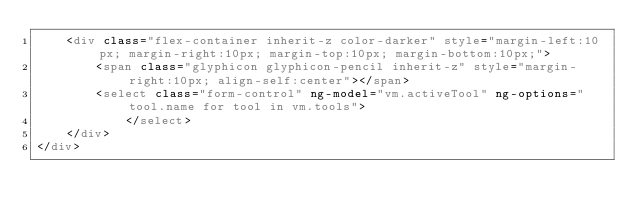<code> <loc_0><loc_0><loc_500><loc_500><_HTML_>    <div class="flex-container inherit-z color-darker" style="margin-left:10px; margin-right:10px; margin-top:10px; margin-bottom:10px;">
        <span class="glyphicon glyphicon-pencil inherit-z" style="margin-right:10px; align-self:center"></span>
        <select class="form-control" ng-model="vm.activeTool" ng-options="tool.name for tool in vm.tools">
            </select>
    </div>
</div></code> 